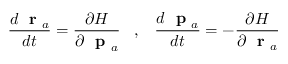<formula> <loc_0><loc_0><loc_500><loc_500>\frac { d r _ { a } } { d t } = \frac { \partial H } { \partial p _ { a } } \, , \, \frac { d p _ { a } } { d t } = - \frac { \partial H } { \partial r _ { a } }</formula> 